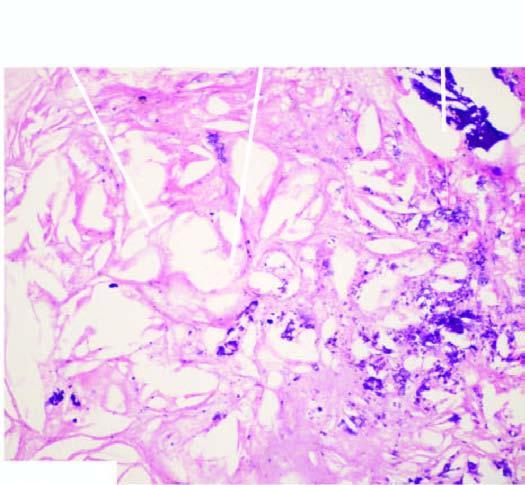there is narrowing of the lumen of coronary due to fully developed atheromatous plaque which has dystrophic calcification in whose core?
Answer the question using a single word or phrase. Its 